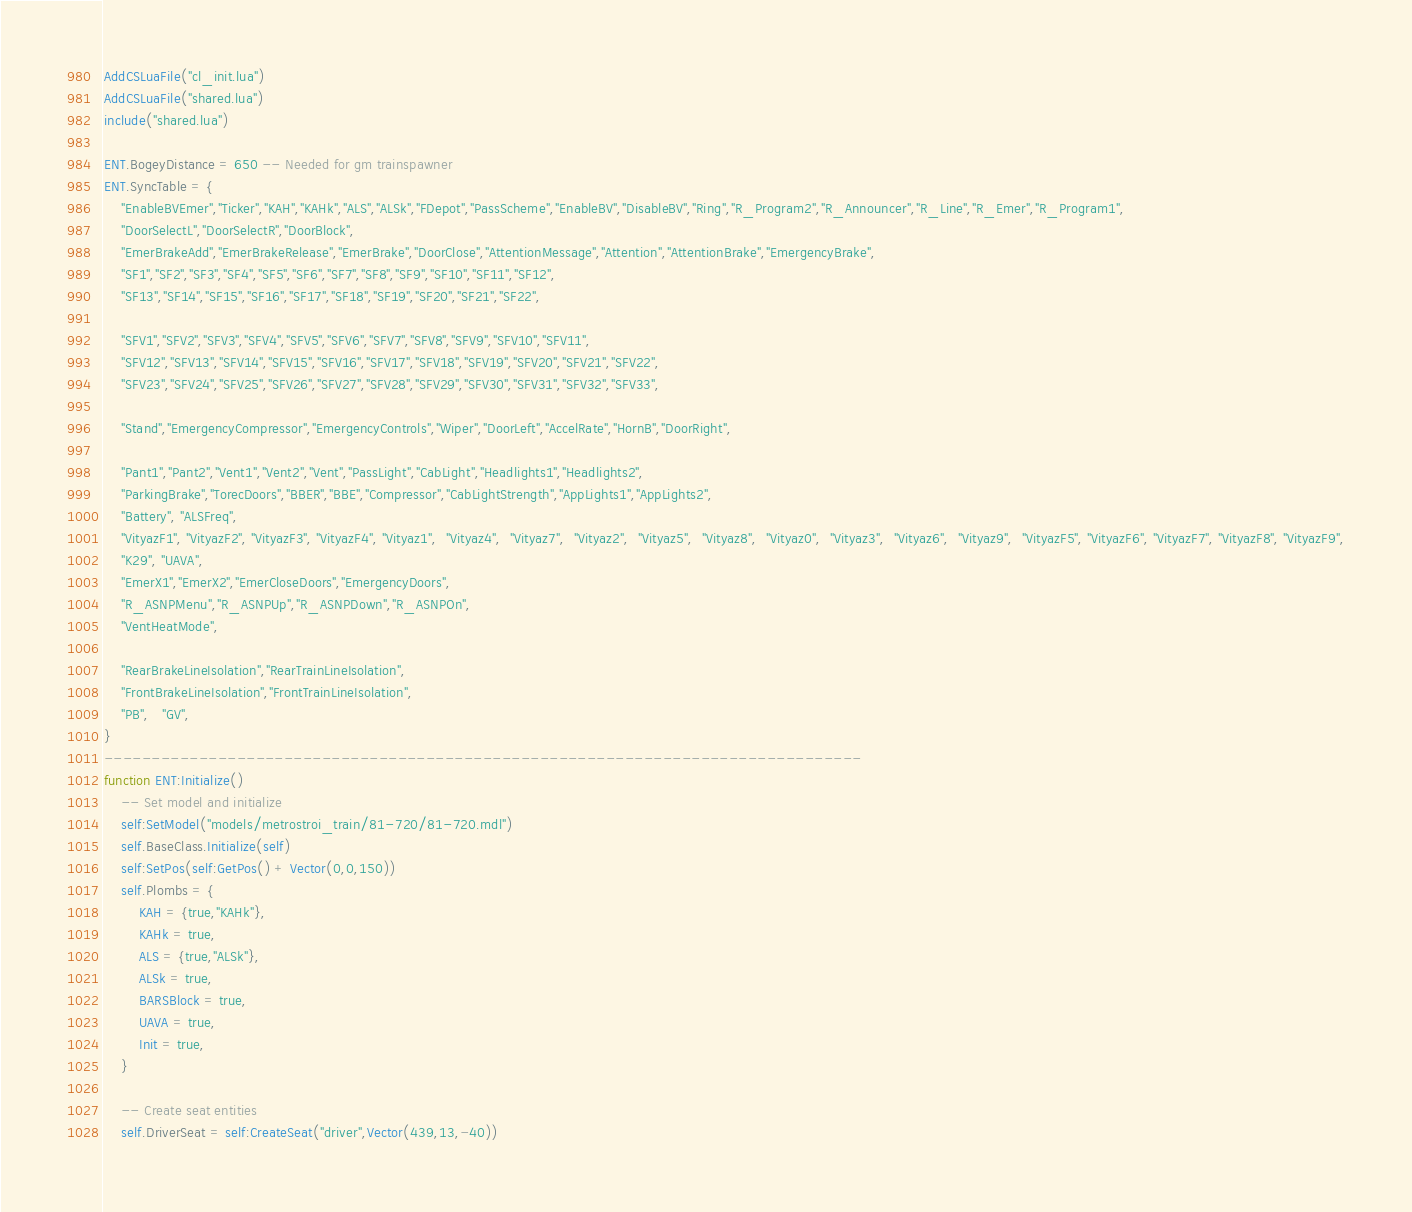<code> <loc_0><loc_0><loc_500><loc_500><_Lua_>AddCSLuaFile("cl_init.lua")
AddCSLuaFile("shared.lua")
include("shared.lua")

ENT.BogeyDistance = 650 -- Needed for gm trainspawner
ENT.SyncTable = {
    "EnableBVEmer","Ticker","KAH","KAHk","ALS","ALSk","FDepot","PassScheme","EnableBV","DisableBV","Ring","R_Program2","R_Announcer","R_Line","R_Emer","R_Program1",
    "DoorSelectL","DoorSelectR","DoorBlock",
    "EmerBrakeAdd","EmerBrakeRelease","EmerBrake","DoorClose","AttentionMessage","Attention","AttentionBrake","EmergencyBrake",
    "SF1","SF2","SF3","SF4","SF5","SF6","SF7","SF8","SF9","SF10","SF11","SF12",
    "SF13","SF14","SF15","SF16","SF17","SF18","SF19","SF20","SF21","SF22",

    "SFV1","SFV2","SFV3","SFV4","SFV5","SFV6","SFV7","SFV8","SFV9","SFV10","SFV11",
    "SFV12","SFV13","SFV14","SFV15","SFV16","SFV17","SFV18","SFV19","SFV20","SFV21","SFV22",
    "SFV23","SFV24","SFV25","SFV26","SFV27","SFV28","SFV29","SFV30","SFV31","SFV32","SFV33",

    "Stand","EmergencyCompressor","EmergencyControls","Wiper","DoorLeft","AccelRate","HornB","DoorRight",

    "Pant1","Pant2","Vent1","Vent2","Vent","PassLight","CabLight","Headlights1","Headlights2",
    "ParkingBrake","TorecDoors","BBER","BBE","Compressor","CabLightStrength","AppLights1","AppLights2",
    "Battery", "ALSFreq",
    "VityazF1", "VityazF2", "VityazF3", "VityazF4", "Vityaz1",  "Vityaz4",  "Vityaz7",  "Vityaz2",  "Vityaz5",  "Vityaz8",  "Vityaz0",  "Vityaz3",  "Vityaz6",  "Vityaz9",  "VityazF5", "VityazF6", "VityazF7", "VityazF8", "VityazF9",
    "K29", "UAVA",
    "EmerX1","EmerX2","EmerCloseDoors","EmergencyDoors",
    "R_ASNPMenu","R_ASNPUp","R_ASNPDown","R_ASNPOn",
    "VentHeatMode",

    "RearBrakeLineIsolation","RearTrainLineIsolation",
    "FrontBrakeLineIsolation","FrontTrainLineIsolation",
    "PB",   "GV",
}
--------------------------------------------------------------------------------
function ENT:Initialize()
    -- Set model and initialize
    self:SetModel("models/metrostroi_train/81-720/81-720.mdl")
    self.BaseClass.Initialize(self)
    self:SetPos(self:GetPos() + Vector(0,0,150))
    self.Plombs = {
        KAH = {true,"KAHk"},
        KAHk = true,
        ALS = {true,"ALSk"},
        ALSk = true,
        BARSBlock = true,
        UAVA = true,
        Init = true,
    }

    -- Create seat entities
    self.DriverSeat = self:CreateSeat("driver",Vector(439,13,-40))</code> 